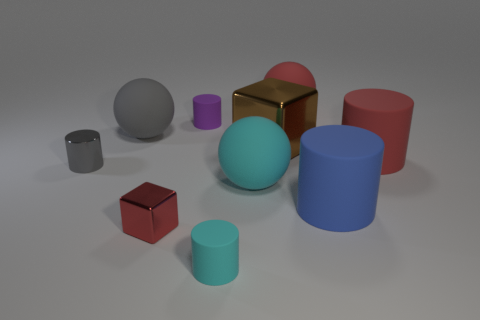Is there a big object that is right of the red matte object that is in front of the big ball right of the large metallic thing?
Your answer should be very brief. No. What number of other things are there of the same shape as the big blue rubber object?
Give a very brief answer. 4. There is a tiny cylinder behind the ball that is on the left side of the block that is in front of the red cylinder; what color is it?
Give a very brief answer. Purple. What number of small red matte cubes are there?
Your answer should be very brief. 0. What number of tiny objects are either red cylinders or yellow rubber things?
Your answer should be compact. 0. There is a gray object that is the same size as the cyan sphere; what shape is it?
Ensure brevity in your answer.  Sphere. Is there any other thing that is the same size as the brown metallic block?
Keep it short and to the point. Yes. What material is the brown block that is on the right side of the big rubber sphere that is in front of the small gray shiny object?
Provide a short and direct response. Metal. Is the size of the blue cylinder the same as the brown cube?
Make the answer very short. Yes. How many objects are small objects that are behind the big metal object or balls?
Your answer should be compact. 4. 